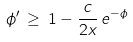Convert formula to latex. <formula><loc_0><loc_0><loc_500><loc_500>\phi ^ { \prime } \, \geq \, 1 - \frac { c } { 2 x } \, e ^ { - \phi }</formula> 